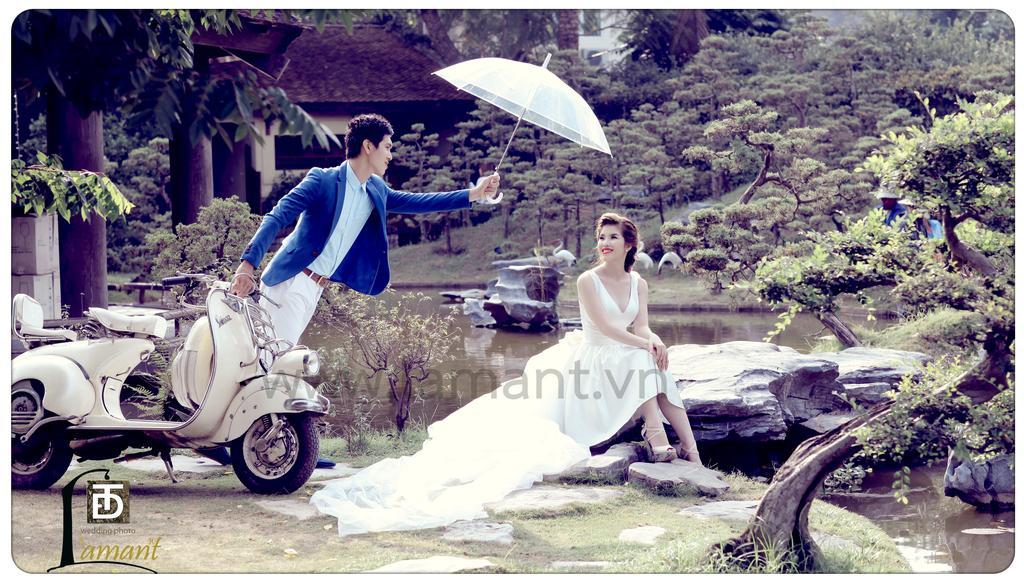How would you summarize this image in a sentence or two? In this picture we can see a girl, wearing white dress and sitting on the stone. Beside there is a boy, standing near the white scooty and wearing a blue suit and holding the umbrella. In the background we can see the water pond, trees and shed house. 